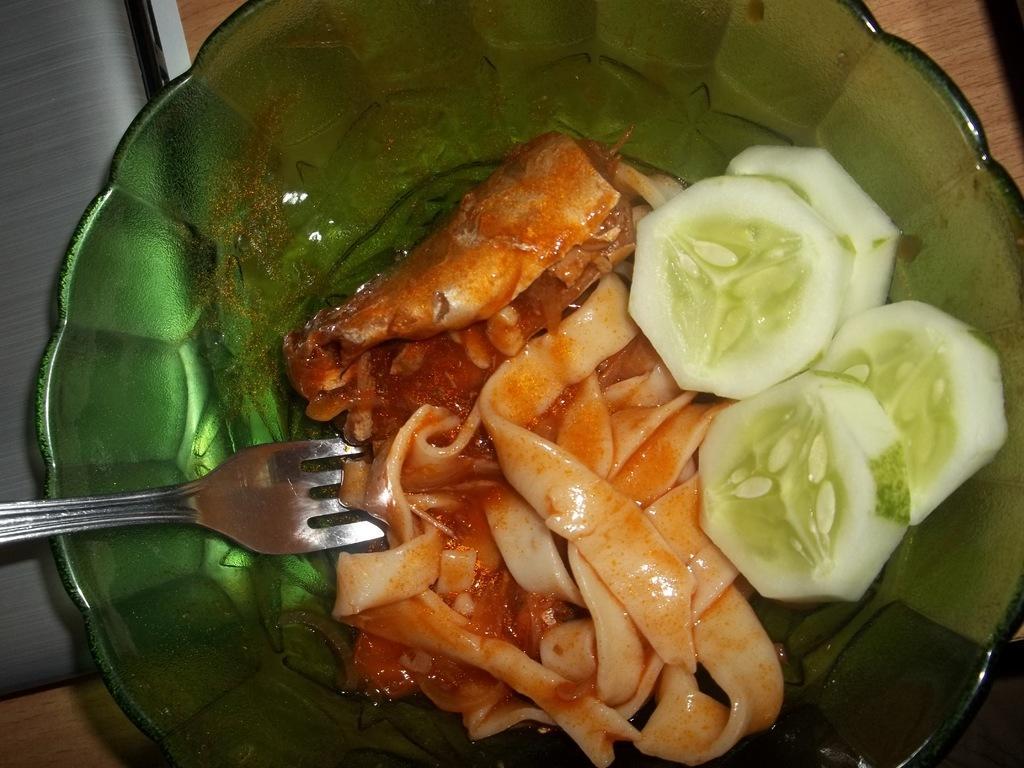Please provide a concise description of this image. In this image, we can see food in the bowl and there is a fork. At the bottom, there is a table. 